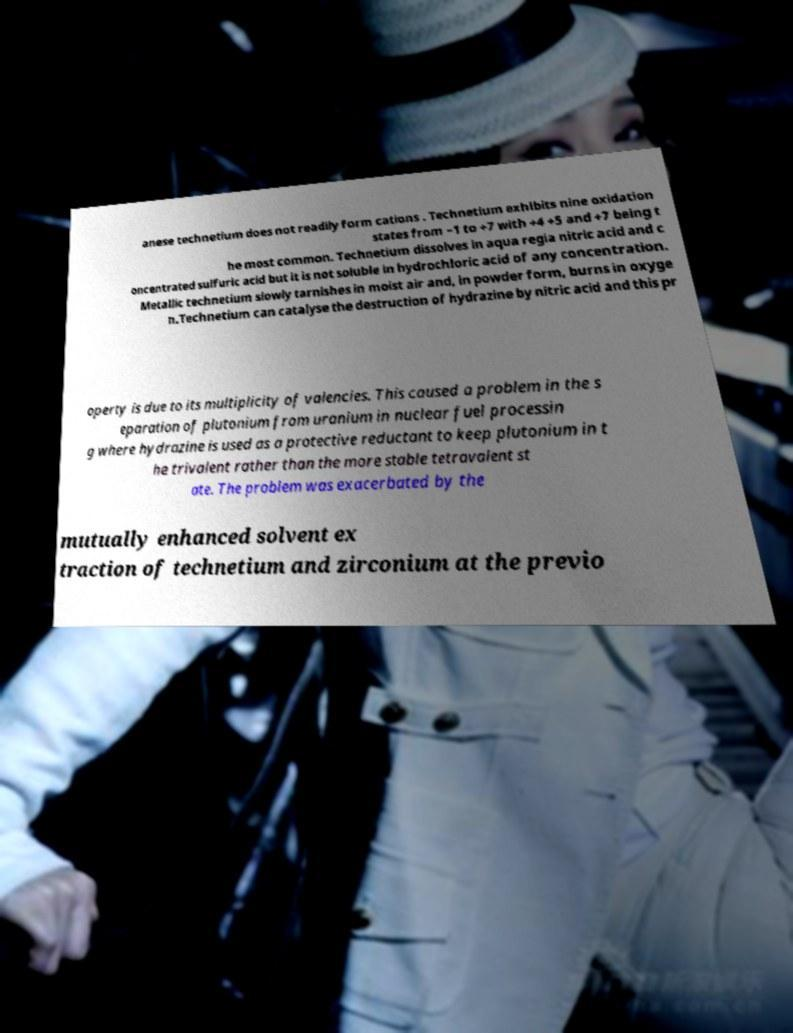Please read and relay the text visible in this image. What does it say? anese technetium does not readily form cations . Technetium exhibits nine oxidation states from −1 to +7 with +4 +5 and +7 being t he most common. Technetium dissolves in aqua regia nitric acid and c oncentrated sulfuric acid but it is not soluble in hydrochloric acid of any concentration. Metallic technetium slowly tarnishes in moist air and, in powder form, burns in oxyge n.Technetium can catalyse the destruction of hydrazine by nitric acid and this pr operty is due to its multiplicity of valencies. This caused a problem in the s eparation of plutonium from uranium in nuclear fuel processin g where hydrazine is used as a protective reductant to keep plutonium in t he trivalent rather than the more stable tetravalent st ate. The problem was exacerbated by the mutually enhanced solvent ex traction of technetium and zirconium at the previo 